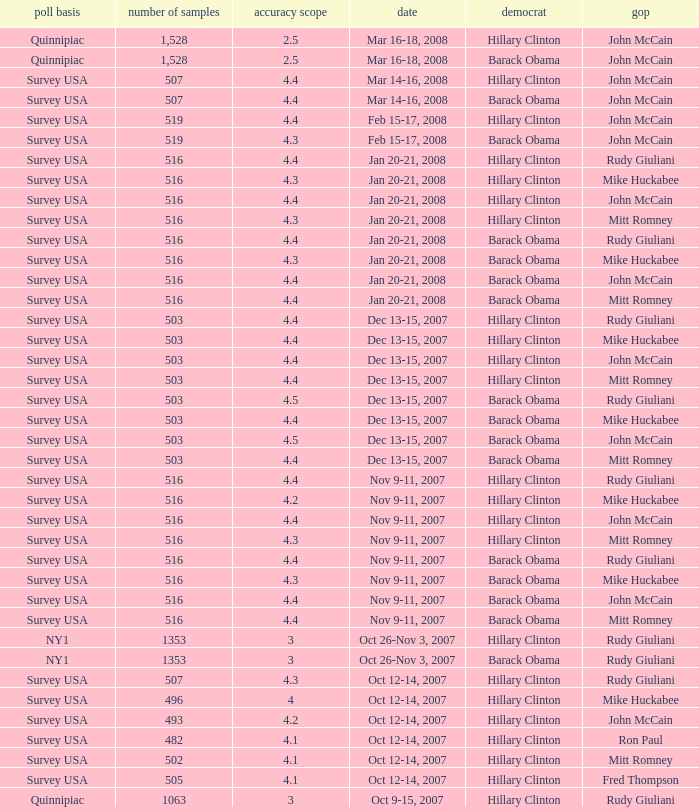Which Democrat was selected in the poll with a sample size smaller than 516 where the Republican chosen was Ron Paul? Hillary Clinton. 